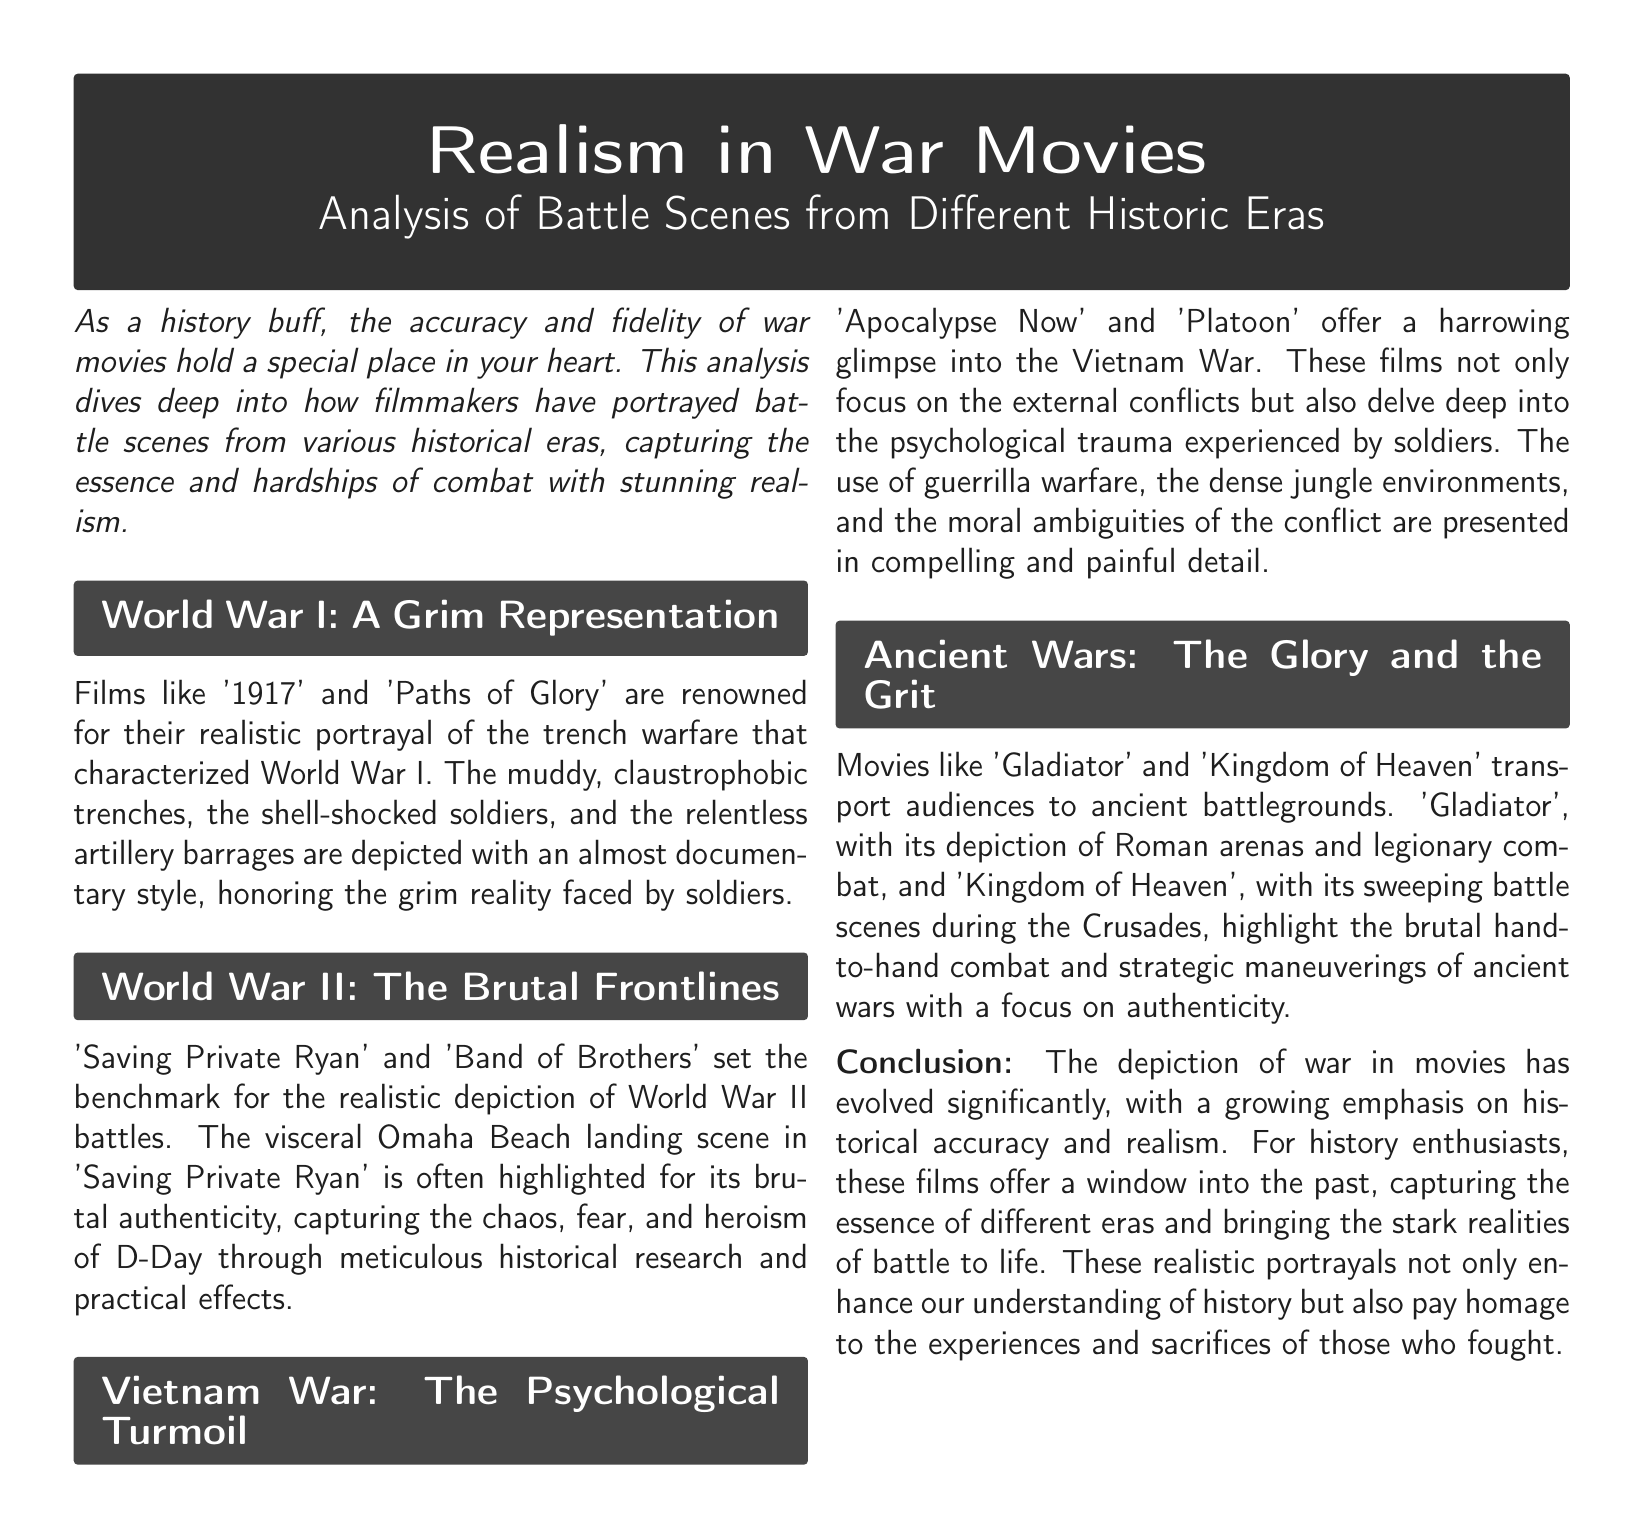What movies are noted for depicting World War I? The document mentions '1917' and 'Paths of Glory' as notable films for their depiction of World War I.
Answer: '1917' and 'Paths of Glory' Which battle is highlighted for its authenticity in World War II films? The document specifically mentions the Omaha Beach landing scene in 'Saving Private Ryan' as a highlight for its brutal authenticity.
Answer: Omaha Beach landing What genre of warfare do 'Apocalypse Now' and 'Platoon' primarily depict? These films focus on psychological trauma experienced in the context of the Vietnam War.
Answer: Psychological trauma Which historical event do 'Gladiator' and 'Kingdom of Heaven' depict? The document states these films highlight battles from ancient wars, specifically centered around Roman arenas and the Crusades.
Answer: Ancient wars What common theme is emphasized across the analysis of war movies? The document discusses a growing emphasis on historical accuracy and realism in war movies as a common theme.
Answer: Historical accuracy and realism How do the battle scenes in 'Saving Private Ryan' and 'Apocalypse Now' differ? The scenes in 'Saving Private Ryan' focus on brutal authenticity while 'Apocalypse Now' delve into psychological trauma.
Answer: Brutal authenticity vs. psychological trauma What is the purpose of the document according to the introduction? The introduction states that the analysis dives deep into how filmmakers have portrayed battle scenes, capturing the essence and hardships of combat.
Answer: Capture the essence and hardships of combat Which war's depiction is described as having "relentless artillery barrages"? The description pertains to World War I, specifically in films like '1917' and 'Paths of Glory'.
Answer: World War I 